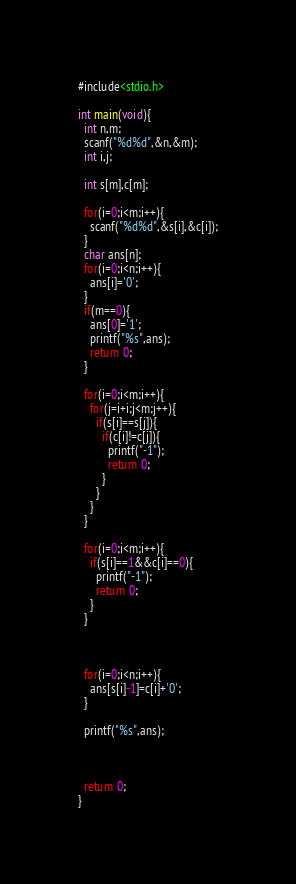Convert code to text. <code><loc_0><loc_0><loc_500><loc_500><_C_>#include<stdio.h>

int main(void){
  int n,m;
  scanf("%d%d",&n,&m);
  int i,j;

  int s[m],c[m];

  for(i=0;i<m;i++){
    scanf("%d%d",&s[i],&c[i]);
  }
  char ans[n];
  for(i=0;i<n;i++){
    ans[i]='0';
  }
  if(m==0){
    ans[0]='1';
    printf("%s",ans);
    return 0;
  }

  for(i=0;i<m;i++){
    for(j=i+i;j<m;j++){
      if(s[i]==s[j]){
        if(c[i]!=c[j]){
          printf("-1");
          return 0;
        }
      }
    }
  }

  for(i=0;i<m;i++){
    if(s[i]==1&&c[i]==0){
      printf("-1");
      return 0;
    }
  }



  for(i=0;i<n;i++){
    ans[s[i]-1]=c[i]+'0';
  }

  printf("%s",ans);



  return 0;
}
</code> 